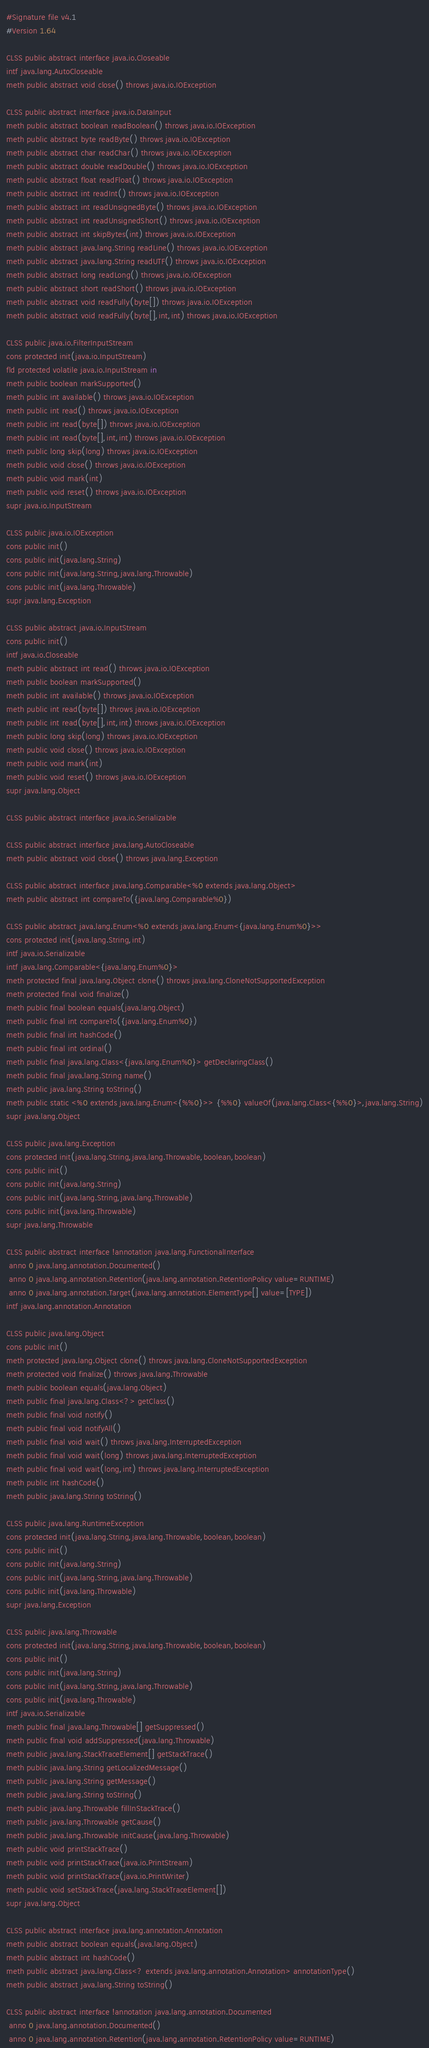Convert code to text. <code><loc_0><loc_0><loc_500><loc_500><_SML_>#Signature file v4.1
#Version 1.64

CLSS public abstract interface java.io.Closeable
intf java.lang.AutoCloseable
meth public abstract void close() throws java.io.IOException

CLSS public abstract interface java.io.DataInput
meth public abstract boolean readBoolean() throws java.io.IOException
meth public abstract byte readByte() throws java.io.IOException
meth public abstract char readChar() throws java.io.IOException
meth public abstract double readDouble() throws java.io.IOException
meth public abstract float readFloat() throws java.io.IOException
meth public abstract int readInt() throws java.io.IOException
meth public abstract int readUnsignedByte() throws java.io.IOException
meth public abstract int readUnsignedShort() throws java.io.IOException
meth public abstract int skipBytes(int) throws java.io.IOException
meth public abstract java.lang.String readLine() throws java.io.IOException
meth public abstract java.lang.String readUTF() throws java.io.IOException
meth public abstract long readLong() throws java.io.IOException
meth public abstract short readShort() throws java.io.IOException
meth public abstract void readFully(byte[]) throws java.io.IOException
meth public abstract void readFully(byte[],int,int) throws java.io.IOException

CLSS public java.io.FilterInputStream
cons protected init(java.io.InputStream)
fld protected volatile java.io.InputStream in
meth public boolean markSupported()
meth public int available() throws java.io.IOException
meth public int read() throws java.io.IOException
meth public int read(byte[]) throws java.io.IOException
meth public int read(byte[],int,int) throws java.io.IOException
meth public long skip(long) throws java.io.IOException
meth public void close() throws java.io.IOException
meth public void mark(int)
meth public void reset() throws java.io.IOException
supr java.io.InputStream

CLSS public java.io.IOException
cons public init()
cons public init(java.lang.String)
cons public init(java.lang.String,java.lang.Throwable)
cons public init(java.lang.Throwable)
supr java.lang.Exception

CLSS public abstract java.io.InputStream
cons public init()
intf java.io.Closeable
meth public abstract int read() throws java.io.IOException
meth public boolean markSupported()
meth public int available() throws java.io.IOException
meth public int read(byte[]) throws java.io.IOException
meth public int read(byte[],int,int) throws java.io.IOException
meth public long skip(long) throws java.io.IOException
meth public void close() throws java.io.IOException
meth public void mark(int)
meth public void reset() throws java.io.IOException
supr java.lang.Object

CLSS public abstract interface java.io.Serializable

CLSS public abstract interface java.lang.AutoCloseable
meth public abstract void close() throws java.lang.Exception

CLSS public abstract interface java.lang.Comparable<%0 extends java.lang.Object>
meth public abstract int compareTo({java.lang.Comparable%0})

CLSS public abstract java.lang.Enum<%0 extends java.lang.Enum<{java.lang.Enum%0}>>
cons protected init(java.lang.String,int)
intf java.io.Serializable
intf java.lang.Comparable<{java.lang.Enum%0}>
meth protected final java.lang.Object clone() throws java.lang.CloneNotSupportedException
meth protected final void finalize()
meth public final boolean equals(java.lang.Object)
meth public final int compareTo({java.lang.Enum%0})
meth public final int hashCode()
meth public final int ordinal()
meth public final java.lang.Class<{java.lang.Enum%0}> getDeclaringClass()
meth public final java.lang.String name()
meth public java.lang.String toString()
meth public static <%0 extends java.lang.Enum<{%%0}>> {%%0} valueOf(java.lang.Class<{%%0}>,java.lang.String)
supr java.lang.Object

CLSS public java.lang.Exception
cons protected init(java.lang.String,java.lang.Throwable,boolean,boolean)
cons public init()
cons public init(java.lang.String)
cons public init(java.lang.String,java.lang.Throwable)
cons public init(java.lang.Throwable)
supr java.lang.Throwable

CLSS public abstract interface !annotation java.lang.FunctionalInterface
 anno 0 java.lang.annotation.Documented()
 anno 0 java.lang.annotation.Retention(java.lang.annotation.RetentionPolicy value=RUNTIME)
 anno 0 java.lang.annotation.Target(java.lang.annotation.ElementType[] value=[TYPE])
intf java.lang.annotation.Annotation

CLSS public java.lang.Object
cons public init()
meth protected java.lang.Object clone() throws java.lang.CloneNotSupportedException
meth protected void finalize() throws java.lang.Throwable
meth public boolean equals(java.lang.Object)
meth public final java.lang.Class<?> getClass()
meth public final void notify()
meth public final void notifyAll()
meth public final void wait() throws java.lang.InterruptedException
meth public final void wait(long) throws java.lang.InterruptedException
meth public final void wait(long,int) throws java.lang.InterruptedException
meth public int hashCode()
meth public java.lang.String toString()

CLSS public java.lang.RuntimeException
cons protected init(java.lang.String,java.lang.Throwable,boolean,boolean)
cons public init()
cons public init(java.lang.String)
cons public init(java.lang.String,java.lang.Throwable)
cons public init(java.lang.Throwable)
supr java.lang.Exception

CLSS public java.lang.Throwable
cons protected init(java.lang.String,java.lang.Throwable,boolean,boolean)
cons public init()
cons public init(java.lang.String)
cons public init(java.lang.String,java.lang.Throwable)
cons public init(java.lang.Throwable)
intf java.io.Serializable
meth public final java.lang.Throwable[] getSuppressed()
meth public final void addSuppressed(java.lang.Throwable)
meth public java.lang.StackTraceElement[] getStackTrace()
meth public java.lang.String getLocalizedMessage()
meth public java.lang.String getMessage()
meth public java.lang.String toString()
meth public java.lang.Throwable fillInStackTrace()
meth public java.lang.Throwable getCause()
meth public java.lang.Throwable initCause(java.lang.Throwable)
meth public void printStackTrace()
meth public void printStackTrace(java.io.PrintStream)
meth public void printStackTrace(java.io.PrintWriter)
meth public void setStackTrace(java.lang.StackTraceElement[])
supr java.lang.Object

CLSS public abstract interface java.lang.annotation.Annotation
meth public abstract boolean equals(java.lang.Object)
meth public abstract int hashCode()
meth public abstract java.lang.Class<? extends java.lang.annotation.Annotation> annotationType()
meth public abstract java.lang.String toString()

CLSS public abstract interface !annotation java.lang.annotation.Documented
 anno 0 java.lang.annotation.Documented()
 anno 0 java.lang.annotation.Retention(java.lang.annotation.RetentionPolicy value=RUNTIME)</code> 